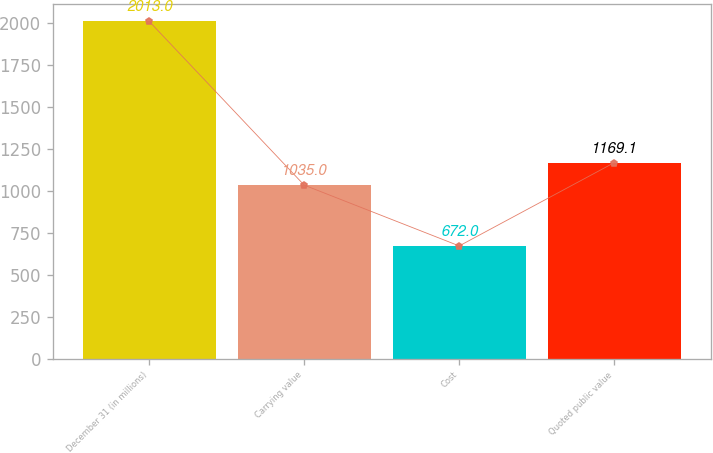<chart> <loc_0><loc_0><loc_500><loc_500><bar_chart><fcel>December 31 (in millions)<fcel>Carrying value<fcel>Cost<fcel>Quoted public value<nl><fcel>2013<fcel>1035<fcel>672<fcel>1169.1<nl></chart> 